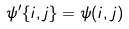<formula> <loc_0><loc_0><loc_500><loc_500>\psi ^ { \prime } \{ i , j \} = \psi ( i , j )</formula> 